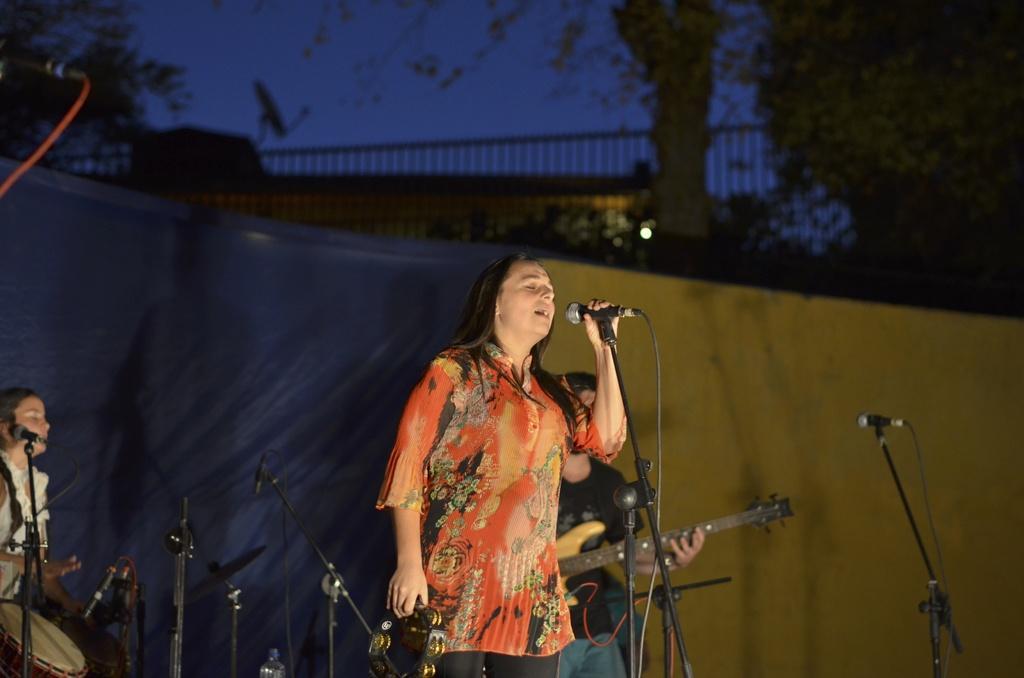Describe this image in one or two sentences. There are 3 people here and in the middle a woman is singing. In the background we see a wall,fencing,trees and a sky. On the left and right 2 persons are playing musical instruments. 